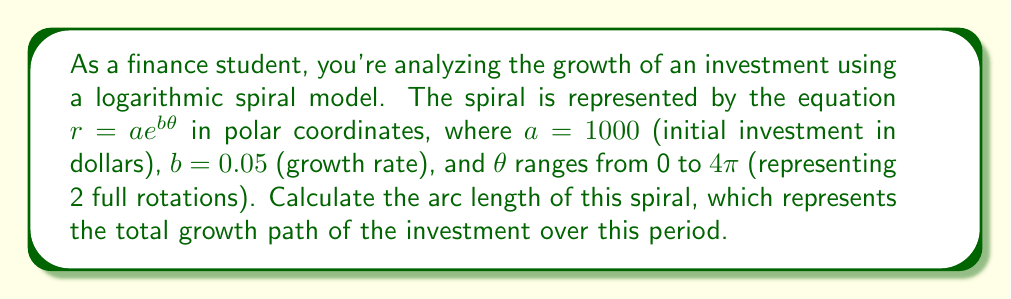Give your solution to this math problem. To solve this problem, we'll follow these steps:

1) The formula for the arc length of a curve in polar coordinates is:

   $$L = \int_{\theta_1}^{\theta_2} \sqrt{r^2 + \left(\frac{dr}{d\theta}\right)^2} d\theta$$

2) For our logarithmic spiral, $r = ae^{b\theta}$. We need to find $\frac{dr}{d\theta}$:

   $$\frac{dr}{d\theta} = abe^{b\theta}$$

3) Substituting these into the arc length formula:

   $$L = \int_{0}^{4\pi} \sqrt{(ae^{b\theta})^2 + (abe^{b\theta})^2} d\theta$$

4) Simplify inside the square root:

   $$L = \int_{0}^{4\pi} \sqrt{a^2e^{2b\theta} + a^2b^2e^{2b\theta}} d\theta$$
   $$L = \int_{0}^{4\pi} \sqrt{a^2e^{2b\theta}(1 + b^2)} d\theta$$
   $$L = a\sqrt{1 + b^2} \int_{0}^{4\pi} e^{b\theta} d\theta$$

5) Integrate:

   $$L = a\sqrt{1 + b^2} \left[\frac{1}{b}e^{b\theta}\right]_{0}^{4\pi}$$
   $$L = \frac{a\sqrt{1 + b^2}}{b} (e^{4\pi b} - 1)$$

6) Now substitute the values $a = 1000$, $b = 0.05$:

   $$L = \frac{1000\sqrt{1 + 0.05^2}}{0.05} (e^{4\pi \cdot 0.05} - 1)$$

7) Calculate the final result:

   $$L \approx 20100.67 \text{ (rounded to 2 decimal places)}$$

This represents the arc length in dollars, showing the total growth path of the investment.
Answer: $20100.67 (rounded to 2 decimal places) 